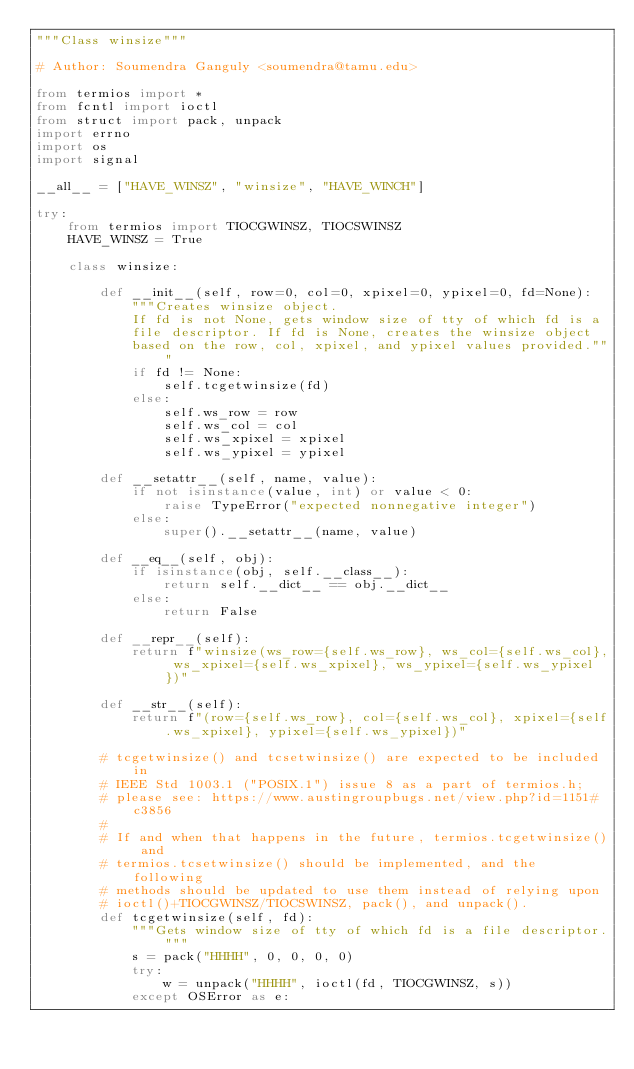Convert code to text. <code><loc_0><loc_0><loc_500><loc_500><_Python_>"""Class winsize"""

# Author: Soumendra Ganguly <soumendra@tamu.edu>

from termios import *
from fcntl import ioctl
from struct import pack, unpack
import errno
import os
import signal

__all__ = ["HAVE_WINSZ", "winsize", "HAVE_WINCH"]

try:
    from termios import TIOCGWINSZ, TIOCSWINSZ
    HAVE_WINSZ = True

    class winsize:

        def __init__(self, row=0, col=0, xpixel=0, ypixel=0, fd=None):
            """Creates winsize object.
            If fd is not None, gets window size of tty of which fd is a
            file descriptor. If fd is None, creates the winsize object
            based on the row, col, xpixel, and ypixel values provided."""
            if fd != None:
                self.tcgetwinsize(fd)
            else:
                self.ws_row = row
                self.ws_col = col
                self.ws_xpixel = xpixel
                self.ws_ypixel = ypixel

        def __setattr__(self, name, value):
            if not isinstance(value, int) or value < 0:
                raise TypeError("expected nonnegative integer")
            else:
                super().__setattr__(name, value)

        def __eq__(self, obj):
            if isinstance(obj, self.__class__):
                return self.__dict__ == obj.__dict__
            else:
                return False

        def __repr__(self):
            return f"winsize(ws_row={self.ws_row}, ws_col={self.ws_col}, ws_xpixel={self.ws_xpixel}, ws_ypixel={self.ws_ypixel})"

        def __str__(self):
            return f"(row={self.ws_row}, col={self.ws_col}, xpixel={self.ws_xpixel}, ypixel={self.ws_ypixel})"

        # tcgetwinsize() and tcsetwinsize() are expected to be included in
        # IEEE Std 1003.1 ("POSIX.1") issue 8 as a part of termios.h;
        # please see: https://www.austingroupbugs.net/view.php?id=1151#c3856
        #
        # If and when that happens in the future, termios.tcgetwinsize() and
        # termios.tcsetwinsize() should be implemented, and the following
        # methods should be updated to use them instead of relying upon
        # ioctl()+TIOCGWINSZ/TIOCSWINSZ, pack(), and unpack().
        def tcgetwinsize(self, fd):
            """Gets window size of tty of which fd is a file descriptor."""
            s = pack("HHHH", 0, 0, 0, 0)
            try:
                w = unpack("HHHH", ioctl(fd, TIOCGWINSZ, s))
            except OSError as e:</code> 